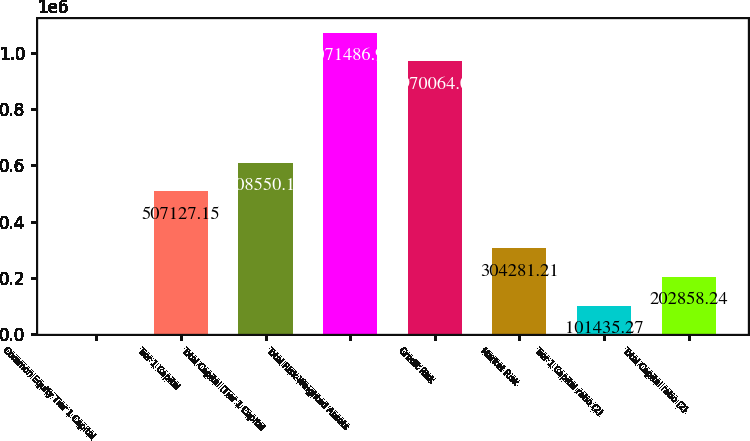Convert chart to OTSL. <chart><loc_0><loc_0><loc_500><loc_500><bar_chart><fcel>Common Equity Tier 1 Capital<fcel>Tier 1 Capital<fcel>Total Capital (Tier 1 Capital<fcel>Total Risk-Weighted Assets<fcel>Credit Risk<fcel>Market Risk<fcel>Tier 1 Capital ratio (2)<fcel>Total Capital ratio (2)<nl><fcel>12.3<fcel>507127<fcel>608550<fcel>1.07149e+06<fcel>970064<fcel>304281<fcel>101435<fcel>202858<nl></chart> 